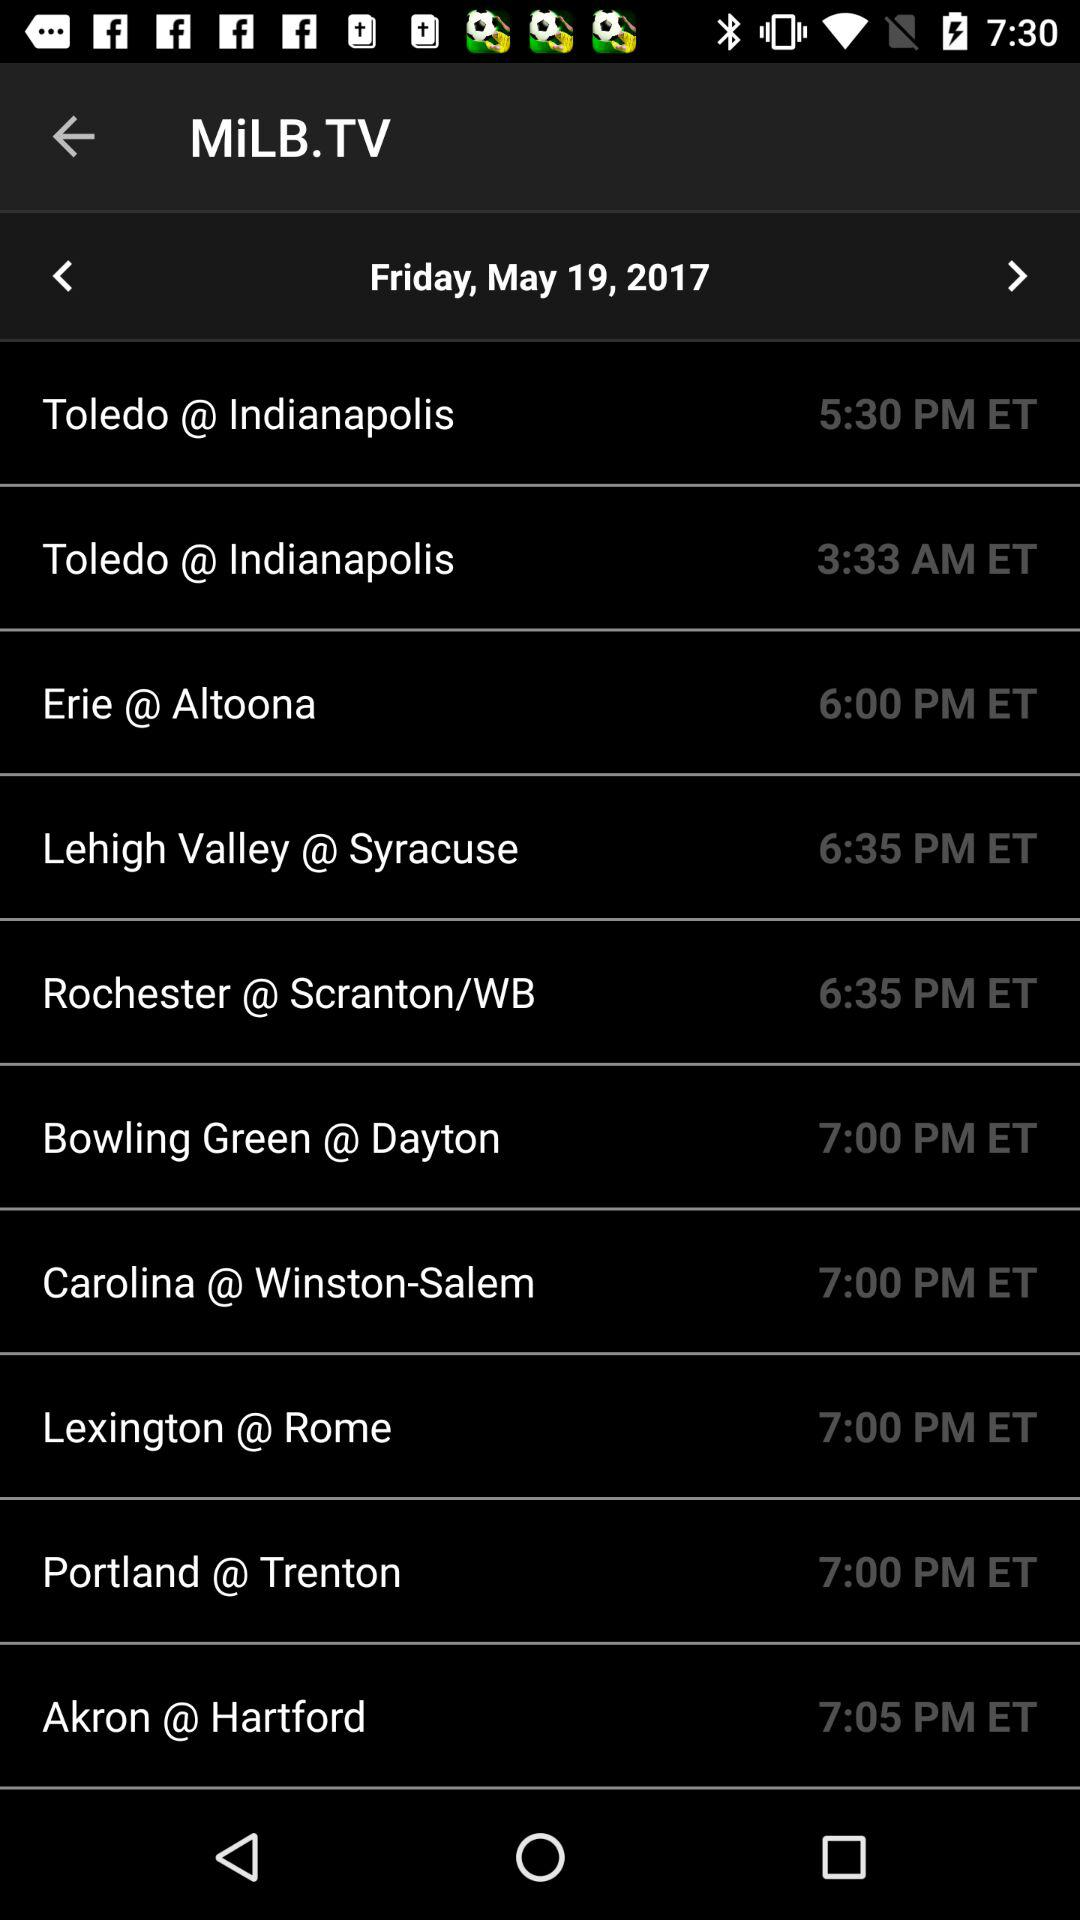What is the time for "Erie @ Altoona"? The time for "Erie @ Altoona" is 6:00 PM ET. 